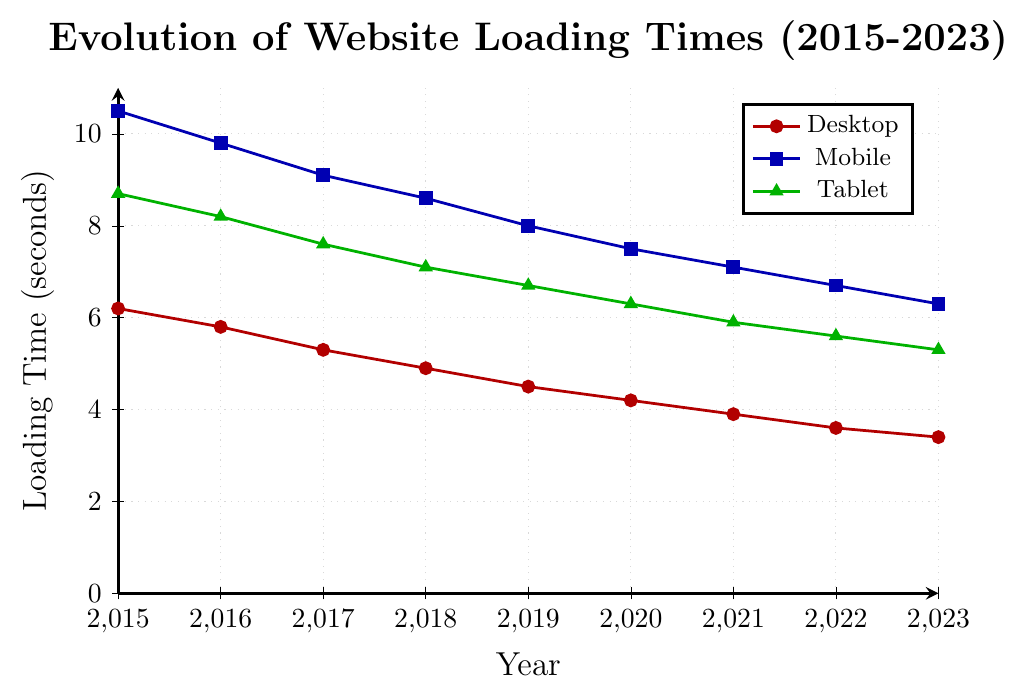what's the average loading time for mobile devices over the entire period? Add up the loading times for mobile devices from 2015 to 2023 and divide by the number of years. (10.5 + 9.8 + 9.1 + 8.6 + 8 + 7.5 + 7.1 + 6.7 + 6.3) / 9 ≈ 8
Answer: 8 seconds which device type showed the greatest reduction in loading time from 2015 to 2023? Compare the loading times in 2015 and 2023 for desktop, mobile, and tablet. Desktop: 6.2 - 3.4 = 2.8. Mobile: 10.5 - 6.3 = 4.2. Tablet: 8.7 - 5.3 = 3.4. Mobile has the greatest reduction.
Answer: Mobile which year showed the fastest loading time for desktop devices? Look at the loading times for desktop devices over the years and identify the smallest value. In 2023, the loading time is 3.4 seconds, which is the lowest.
Answer: 2023 how did the tablet loading time change between 2017 and 2019? Subtract the 2019 tablet loading time from the 2017 tablet loading time: 7.6 - 6.7 = 0.9. The loading time decreased by 0.9 seconds.
Answer: Decreased by 0.9 seconds which device type consistently had the slowest loading times across the entire period? Compare the loading time trends for desktop, mobile, and tablet devices from 2015 to 2023. Mobile devices consistently have the highest loading times.
Answer: Mobile what is the overall trend for desktop loading times from 2015 to 2023? Observe the pattern of loading times for desktop devices from 2015 to 2023. The trend shows a consistent decrease over the entire period.
Answer: Decreasing trend in which year did all three device types show a loading time of 7 seconds or more? Check the loading times for each device type from 2015 to 2023 to find a year when all are 7 seconds or more. In 2015, desktop is 6.2 and tablet is 8.7, but mobile is above 7.
Answer: 2015 what is the difference in loading time between mobile and tablet devices in 2020? Subtract the tablet loading time from the mobile loading time in 2020: 7.5 - 6.3 = 1.2. The difference is 1.2 seconds.
Answer: 1.2 seconds 